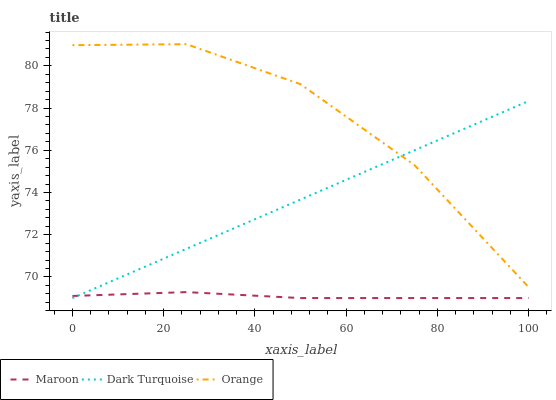Does Maroon have the minimum area under the curve?
Answer yes or no. Yes. Does Orange have the maximum area under the curve?
Answer yes or no. Yes. Does Dark Turquoise have the minimum area under the curve?
Answer yes or no. No. Does Dark Turquoise have the maximum area under the curve?
Answer yes or no. No. Is Dark Turquoise the smoothest?
Answer yes or no. Yes. Is Orange the roughest?
Answer yes or no. Yes. Is Maroon the smoothest?
Answer yes or no. No. Is Maroon the roughest?
Answer yes or no. No. Does Dark Turquoise have the lowest value?
Answer yes or no. Yes. Does Orange have the highest value?
Answer yes or no. Yes. Does Dark Turquoise have the highest value?
Answer yes or no. No. Is Maroon less than Orange?
Answer yes or no. Yes. Is Orange greater than Maroon?
Answer yes or no. Yes. Does Dark Turquoise intersect Maroon?
Answer yes or no. Yes. Is Dark Turquoise less than Maroon?
Answer yes or no. No. Is Dark Turquoise greater than Maroon?
Answer yes or no. No. Does Maroon intersect Orange?
Answer yes or no. No. 